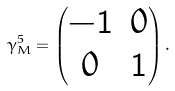<formula> <loc_0><loc_0><loc_500><loc_500>\gamma _ { M } ^ { 5 } = \begin{pmatrix} - { \mathbf 1 } & 0 \\ 0 & { \mathbf 1 } \end{pmatrix} .</formula> 